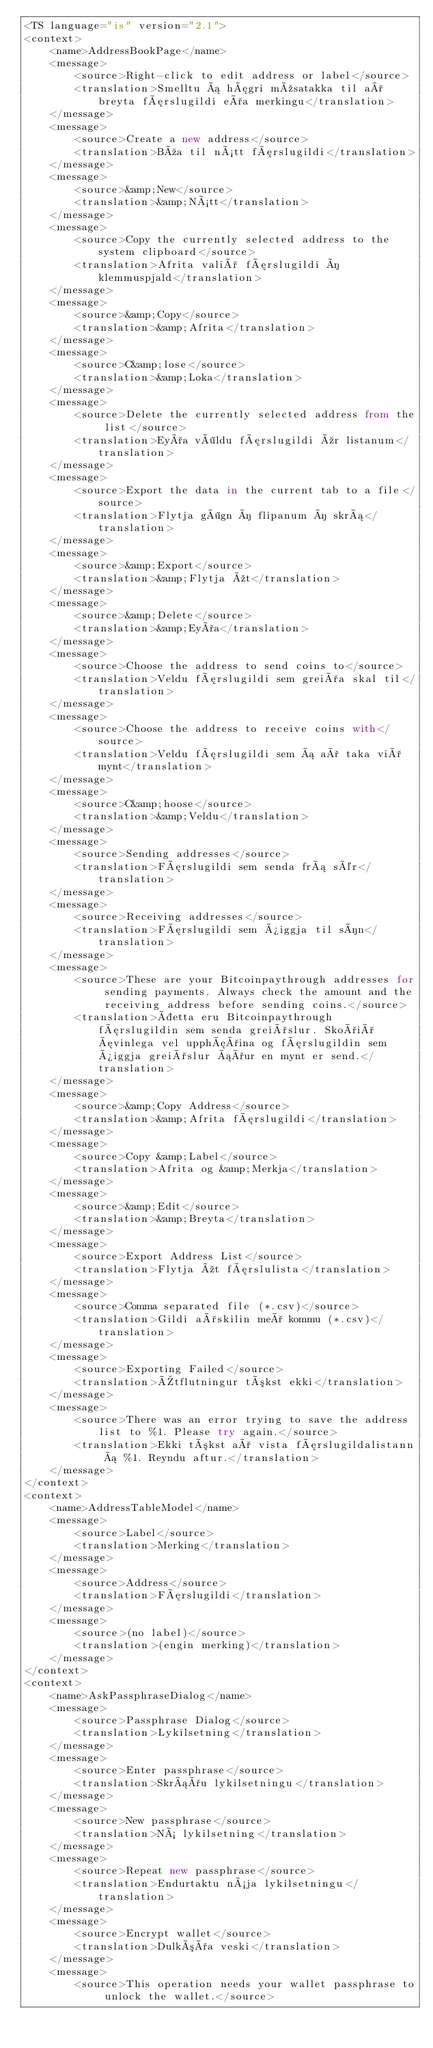Convert code to text. <code><loc_0><loc_0><loc_500><loc_500><_TypeScript_><TS language="is" version="2.1">
<context>
    <name>AddressBookPage</name>
    <message>
        <source>Right-click to edit address or label</source>
        <translation>Smelltu á hægri músatakka til að breyta færslugildi eða merkingu</translation>
    </message>
    <message>
        <source>Create a new address</source>
        <translation>Búa til nýtt færslugildi</translation>
    </message>
    <message>
        <source>&amp;New</source>
        <translation>&amp;Nýtt</translation>
    </message>
    <message>
        <source>Copy the currently selected address to the system clipboard</source>
        <translation>Afrita valið færslugildi í klemmuspjald</translation>
    </message>
    <message>
        <source>&amp;Copy</source>
        <translation>&amp;Afrita</translation>
    </message>
    <message>
        <source>C&amp;lose</source>
        <translation>&amp;Loka</translation>
    </message>
    <message>
        <source>Delete the currently selected address from the list</source>
        <translation>Eyða völdu færslugildi úr listanum</translation>
    </message>
    <message>
        <source>Export the data in the current tab to a file</source>
        <translation>Flytja gögn í flipanum í skrá</translation>
    </message>
    <message>
        <source>&amp;Export</source>
        <translation>&amp;Flytja út</translation>
    </message>
    <message>
        <source>&amp;Delete</source>
        <translation>&amp;Eyða</translation>
    </message>
    <message>
        <source>Choose the address to send coins to</source>
        <translation>Veldu færslugildi sem greiða skal til</translation>
    </message>
    <message>
        <source>Choose the address to receive coins with</source>
        <translation>Veldu færslugildi sem á að taka við mynt</translation>
    </message>
    <message>
        <source>C&amp;hoose</source>
        <translation>&amp;Veldu</translation>
    </message>
    <message>
        <source>Sending addresses</source>
        <translation>Færslugildi sem senda frá sér</translation>
    </message>
    <message>
        <source>Receiving addresses</source>
        <translation>Færslugildi sem þiggja til sín</translation>
    </message>
    <message>
        <source>These are your Bitcoinpaythrough addresses for sending payments. Always check the amount and the receiving address before sending coins.</source>
        <translation>Þetta eru Bitcoinpaythrough færslugildin sem senda greiðslur. Skoðið ævinlega vel upphæðina og færslugildin sem þiggja greiðslur áður en mynt er send.</translation>
    </message>
    <message>
        <source>&amp;Copy Address</source>
        <translation>&amp;Afrita færslugildi</translation>
    </message>
    <message>
        <source>Copy &amp;Label</source>
        <translation>Afrita og &amp;Merkja</translation>
    </message>
    <message>
        <source>&amp;Edit</source>
        <translation>&amp;Breyta</translation>
    </message>
    <message>
        <source>Export Address List</source>
        <translation>Flytja út færslulista</translation>
    </message>
    <message>
        <source>Comma separated file (*.csv)</source>
        <translation>Gildi aðskilin með kommu (*.csv)</translation>
    </message>
    <message>
        <source>Exporting Failed</source>
        <translation>Útflutningur tókst ekki</translation>
    </message>
    <message>
        <source>There was an error trying to save the address list to %1. Please try again.</source>
        <translation>Ekki tókst að vista færslugildalistann á %1. Reyndu aftur.</translation>
    </message>
</context>
<context>
    <name>AddressTableModel</name>
    <message>
        <source>Label</source>
        <translation>Merking</translation>
    </message>
    <message>
        <source>Address</source>
        <translation>Færslugildi</translation>
    </message>
    <message>
        <source>(no label)</source>
        <translation>(engin merking)</translation>
    </message>
</context>
<context>
    <name>AskPassphraseDialog</name>
    <message>
        <source>Passphrase Dialog</source>
        <translation>Lykilsetning</translation>
    </message>
    <message>
        <source>Enter passphrase</source>
        <translation>Skráðu lykilsetningu</translation>
    </message>
    <message>
        <source>New passphrase</source>
        <translation>Ný lykilsetning</translation>
    </message>
    <message>
        <source>Repeat new passphrase</source>
        <translation>Endurtaktu nýja lykilsetningu</translation>
    </message>
    <message>
        <source>Encrypt wallet</source>
        <translation>Dulkóða veski</translation>
    </message>
    <message>
        <source>This operation needs your wallet passphrase to unlock the wallet.</source></code> 